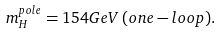<formula> <loc_0><loc_0><loc_500><loc_500>m _ { H } ^ { p o l e } = 1 5 4 G e V \, ( o n e - l o o p ) .</formula> 